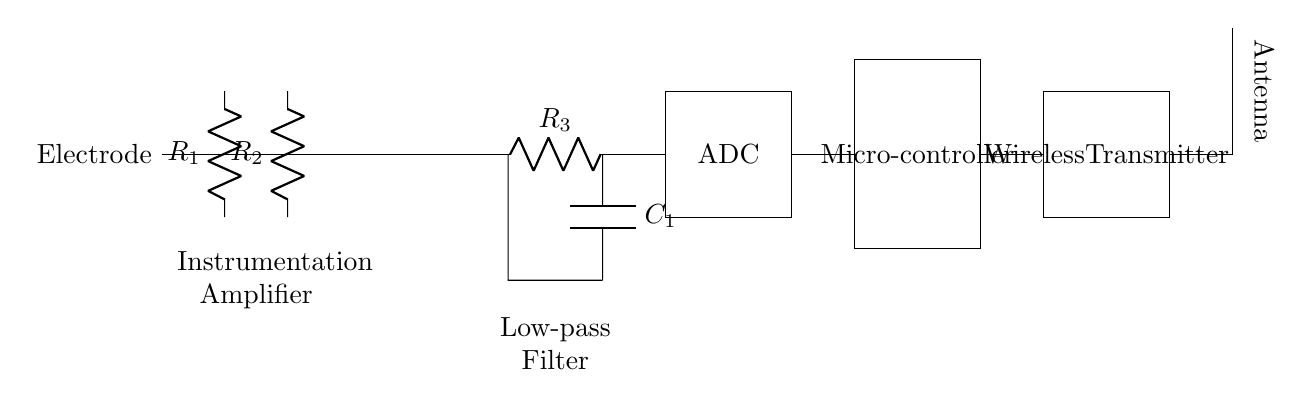What are the primary components used in this circuit? The primary components visible in the circuit include resistors, an operational amplifier, a capacitor, an analog-to-digital converter, a microcontroller, a wireless transmitter, and an antenna. These components work together to sense muscle activity and transmit data wirelessly.
Answer: Resistors, operational amplifier, capacitor, ADC, microcontroller, wireless transmitter, antenna What function does the operational amplifier serve in this circuit? The operational amplifier is an instrumentation amplifier, which means it amplifies small differential signals from the electrodes while rejecting common-mode noise. This is crucial for accurately sensing muscle activity during running.
Answer: Amplifies muscle signals How many resistors are present in the circuit diagram? There are three resistors labeled as R1, R2, and R3 in the circuit. Each resistor contributes to different stages of signal processing in the system, such as amplification and filtering.
Answer: Three What type of filter is implemented in this circuit? A low-pass filter is implemented, which eliminates high-frequency noise from the signals, allowing only the desired low-frequency muscle activity signals to pass through to the ADC.
Answer: Low-pass filter What is the purpose of the wireless transmitter in the circuit? The wireless transmitter is designed to send processed data from the microcontroller to a receiver without the need for wired connections, facilitating real-time gait analysis during a run.
Answer: Transmits data wirelessly What is the role of the ADC in this circuit? The ADC, or analog-to-digital converter, converts the analog signals from the low-pass filter into digital signals that the microcontroller can process. This conversion is essential for analyzing the muscle activity data collected during running.
Answer: Converts analog to digital 